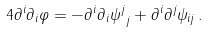<formula> <loc_0><loc_0><loc_500><loc_500>4 \partial ^ { i } \partial _ { i } \varphi = - \partial ^ { i } \partial _ { i } { \psi ^ { j } } _ { j } + \partial ^ { i } \partial ^ { j } \psi _ { i j } \, .</formula> 